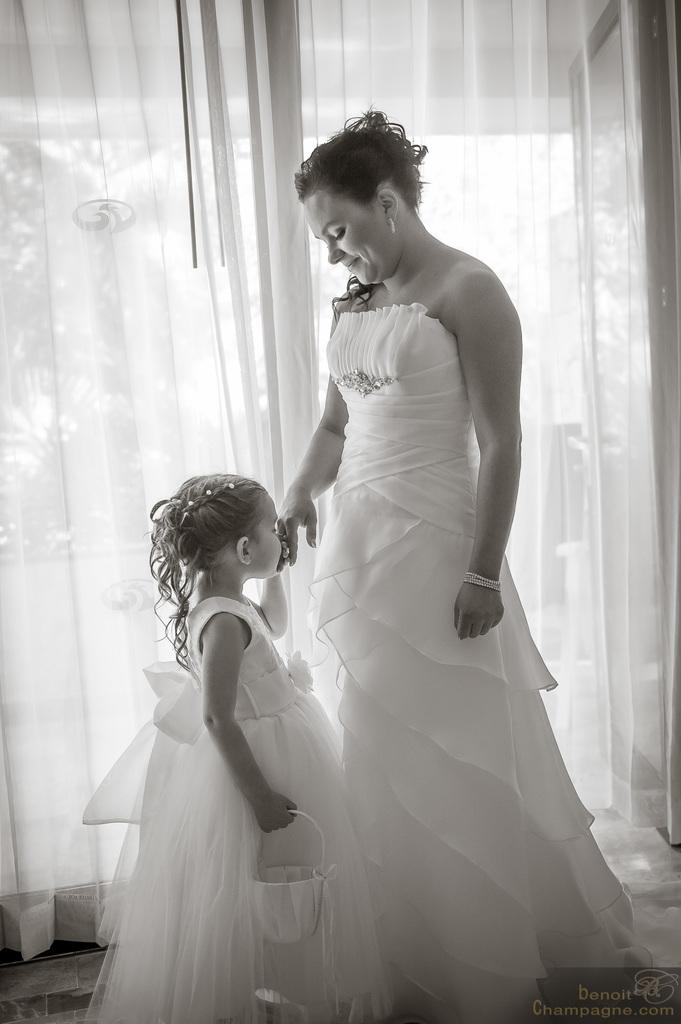Who are the people in the image? There is a woman and a girl in the image. Where are the woman and girl located in the image? They are in the middle of the image. What can be seen in the background of the image? There is a curtain in the background of the image. What is the color scheme of the image? The image is black and white. What type of weather can be seen in the image? The image is black and white, so it does not depict any weather conditions. Can you tell me how many zebras are present in the image? There are no zebras present in the image; it features a woman and a girl. What type of tooth is visible in the image? There is no tooth visible in the image. 